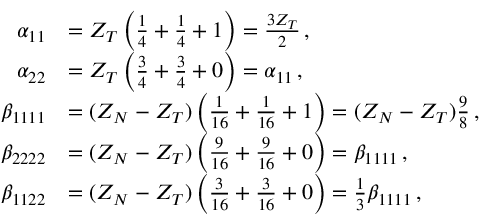<formula> <loc_0><loc_0><loc_500><loc_500>\begin{array} { r l } { \alpha _ { 1 1 } } & { = Z _ { T } \left ( \frac { 1 } { 4 } + \frac { 1 } { 4 } + 1 \right ) = \frac { 3 Z _ { T } } { 2 } \, , } \\ { \alpha _ { 2 2 } } & { = Z _ { T } \left ( \frac { 3 } { 4 } + \frac { 3 } { 4 } + 0 \right ) = \alpha _ { 1 1 } \, , } \\ { \beta _ { 1 1 1 1 } } & { = ( Z _ { N } - Z _ { T } ) \left ( \frac { 1 } { 1 6 } + \frac { 1 } { 1 6 } + 1 \right ) = ( Z _ { N } - Z _ { T } ) \frac { 9 } { 8 } \, , } \\ { \beta _ { 2 2 2 2 } } & { = ( Z _ { N } - Z _ { T } ) \left ( \frac { 9 } { 1 6 } + \frac { 9 } { 1 6 } + 0 \right ) = \beta _ { 1 1 1 1 } \, , } \\ { \beta _ { 1 1 2 2 } } & { = ( Z _ { N } - Z _ { T } ) \left ( \frac { 3 } { 1 6 } + \frac { 3 } { 1 6 } + 0 \right ) = \frac { 1 } { 3 } \beta _ { 1 1 1 1 } \, , } \end{array}</formula> 